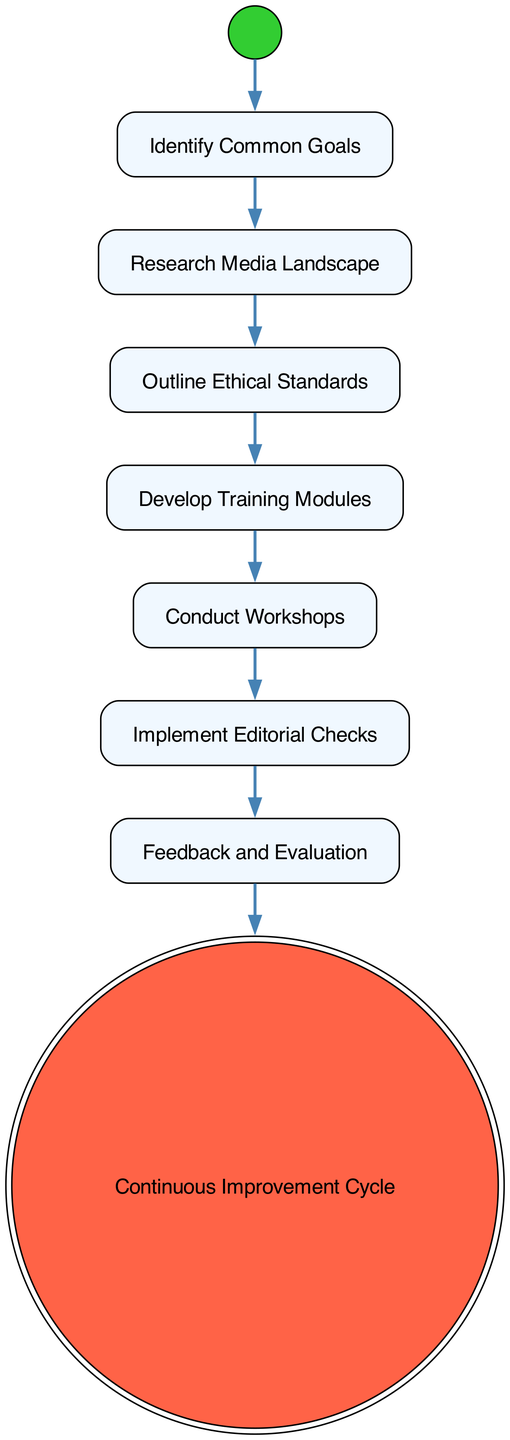What is the first action node in the diagram? The diagram starts with the 'Identify Common Goals' action node, which is the first action that follows the initial node.
Answer: Identify Common Goals How many action nodes are present in the diagram? By inspecting the diagram, there are a total of six action nodes; they include 'Identify Common Goals', 'Research Media Landscape', 'Outline Ethical Standards', 'Develop Training Modules', 'Conduct Workshops', and 'Implement Editorial Checks'.
Answer: Six What is the last node type in the diagram? The last node in the diagram is the 'Continuous Improvement Cycle', which is an Activity Final Node, indicating the end of the process.
Answer: Activity Final Node What action is taken after conducting workshops? After 'Conduct Workshops', the next action node is 'Implement Editorial Checks' according to the flow of the diagram.
Answer: Implement Editorial Checks How does feedback contribute to the process? Feedback is gathered after the 'Conduct Workshops' step and is then used in the 'Feedback and Evaluation' node to assess the impact of the training, which is crucial for continual enhancement within the loop.
Answer: Feedback and Evaluation Which action node focuses on training resources? The action node 'Develop Training Modules' is specifically centered around creating educational materials aimed at journalists for ethical reporting training.
Answer: Develop Training Modules What occurs after outlining ethical standards? After 'Outline Ethical Standards', the next step is to 'Develop Training Modules', which means that the ethical standards guide the creation of effective training modules.
Answer: Develop Training Modules What do the preliminary discussions focus on in the initial node? The discussions in the initial node focus on aligning shared objectives for responsible reporting, particularly integrity and truthfulness, which are highlighted in 'Identify Common Goals'.
Answer: Identify Common Goals 